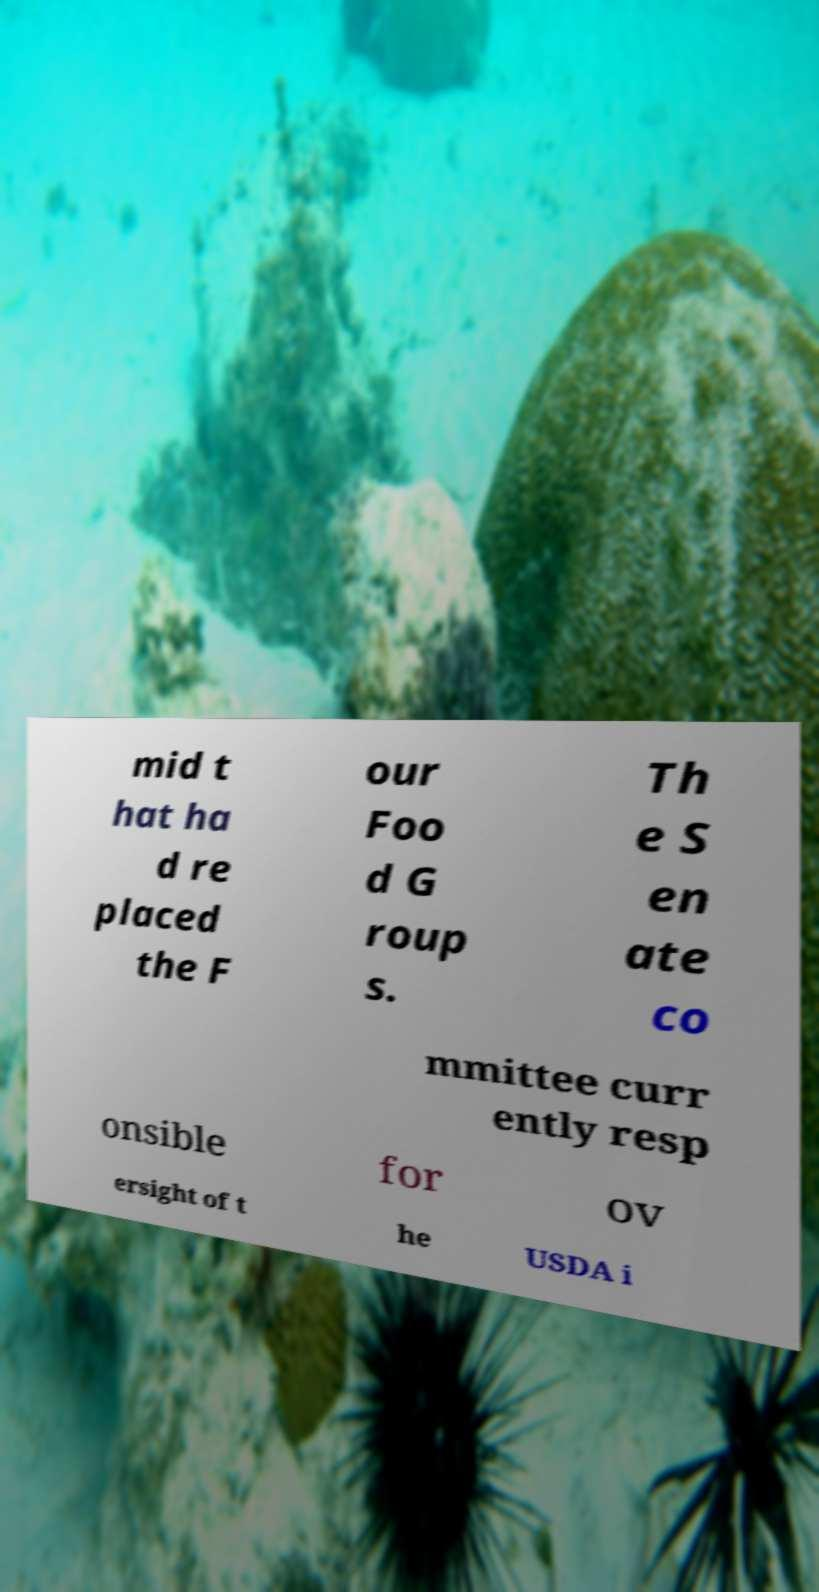I need the written content from this picture converted into text. Can you do that? mid t hat ha d re placed the F our Foo d G roup s. Th e S en ate co mmittee curr ently resp onsible for ov ersight of t he USDA i 